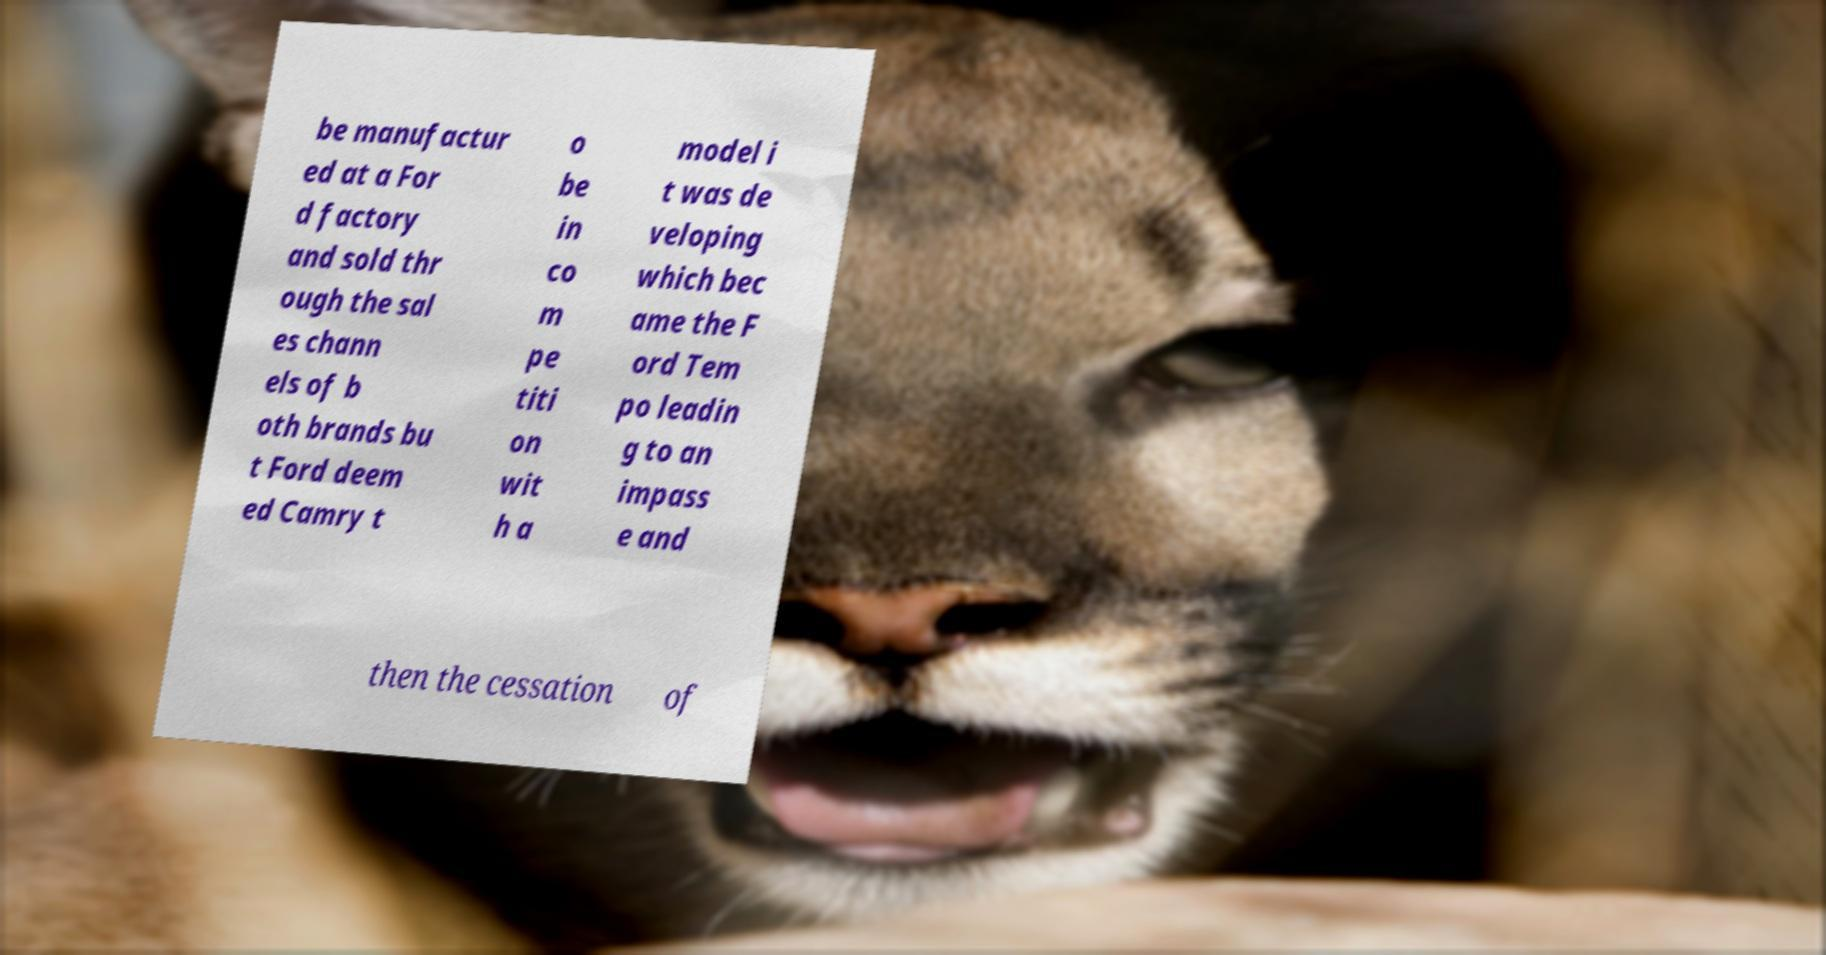Could you assist in decoding the text presented in this image and type it out clearly? be manufactur ed at a For d factory and sold thr ough the sal es chann els of b oth brands bu t Ford deem ed Camry t o be in co m pe titi on wit h a model i t was de veloping which bec ame the F ord Tem po leadin g to an impass e and then the cessation of 